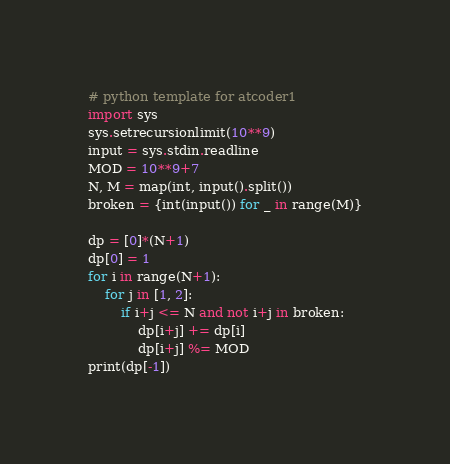Convert code to text. <code><loc_0><loc_0><loc_500><loc_500><_Python_># python template for atcoder1
import sys
sys.setrecursionlimit(10**9)
input = sys.stdin.readline
MOD = 10**9+7
N, M = map(int, input().split())
broken = {int(input()) for _ in range(M)}

dp = [0]*(N+1)
dp[0] = 1
for i in range(N+1):
    for j in [1, 2]:
        if i+j <= N and not i+j in broken:
            dp[i+j] += dp[i]
            dp[i+j] %= MOD
print(dp[-1])
</code> 